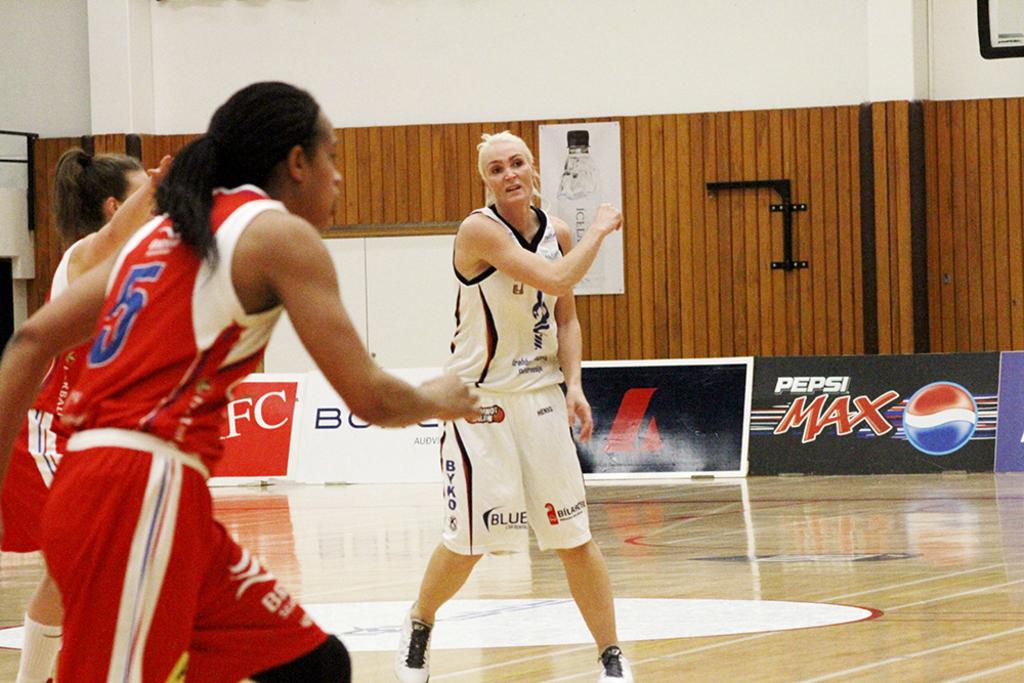What soda is advertised in this photo?
Provide a succinct answer. Pepsi max. What number is on the red jersey?
Make the answer very short. 5. 